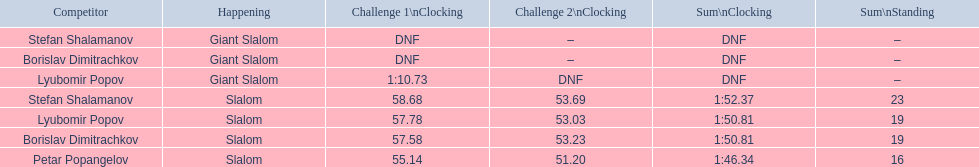Which event is the giant slalom? Giant Slalom, Giant Slalom, Giant Slalom. Which one is lyubomir popov? Lyubomir Popov. What is race 1 tim? 1:10.73. 